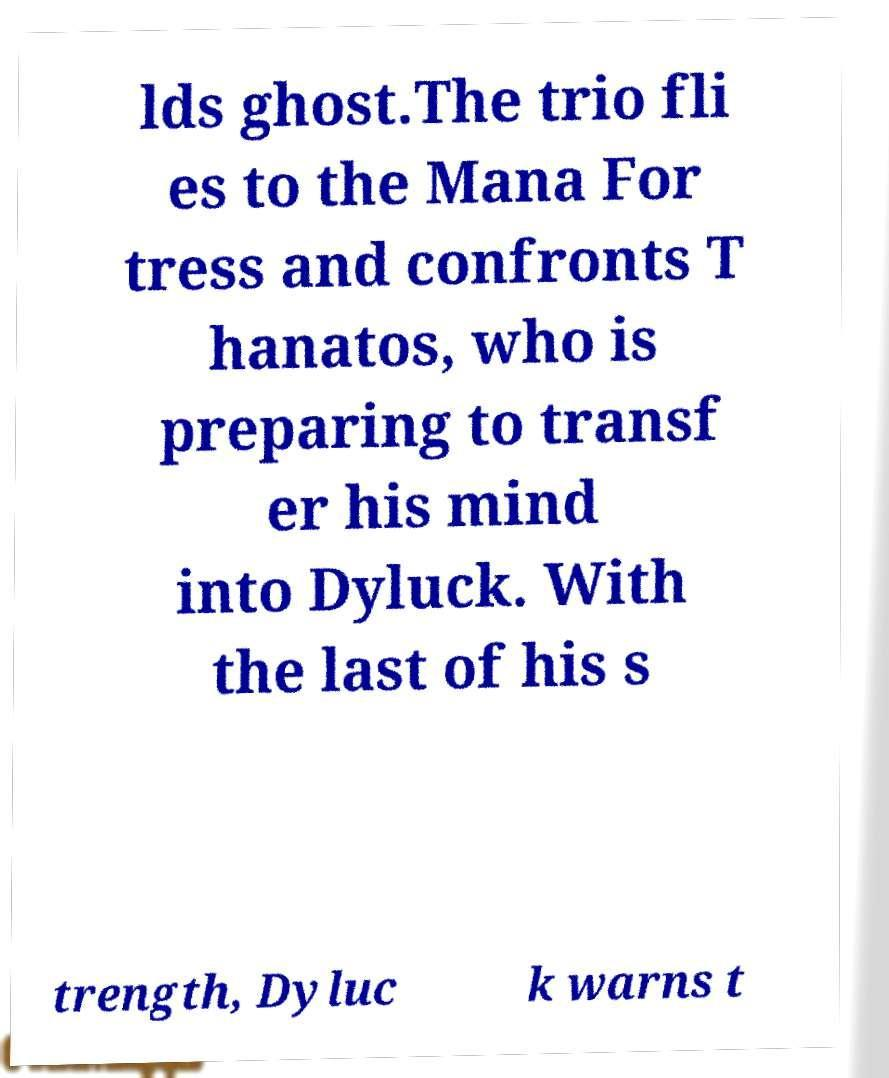Could you assist in decoding the text presented in this image and type it out clearly? lds ghost.The trio fli es to the Mana For tress and confronts T hanatos, who is preparing to transf er his mind into Dyluck. With the last of his s trength, Dyluc k warns t 